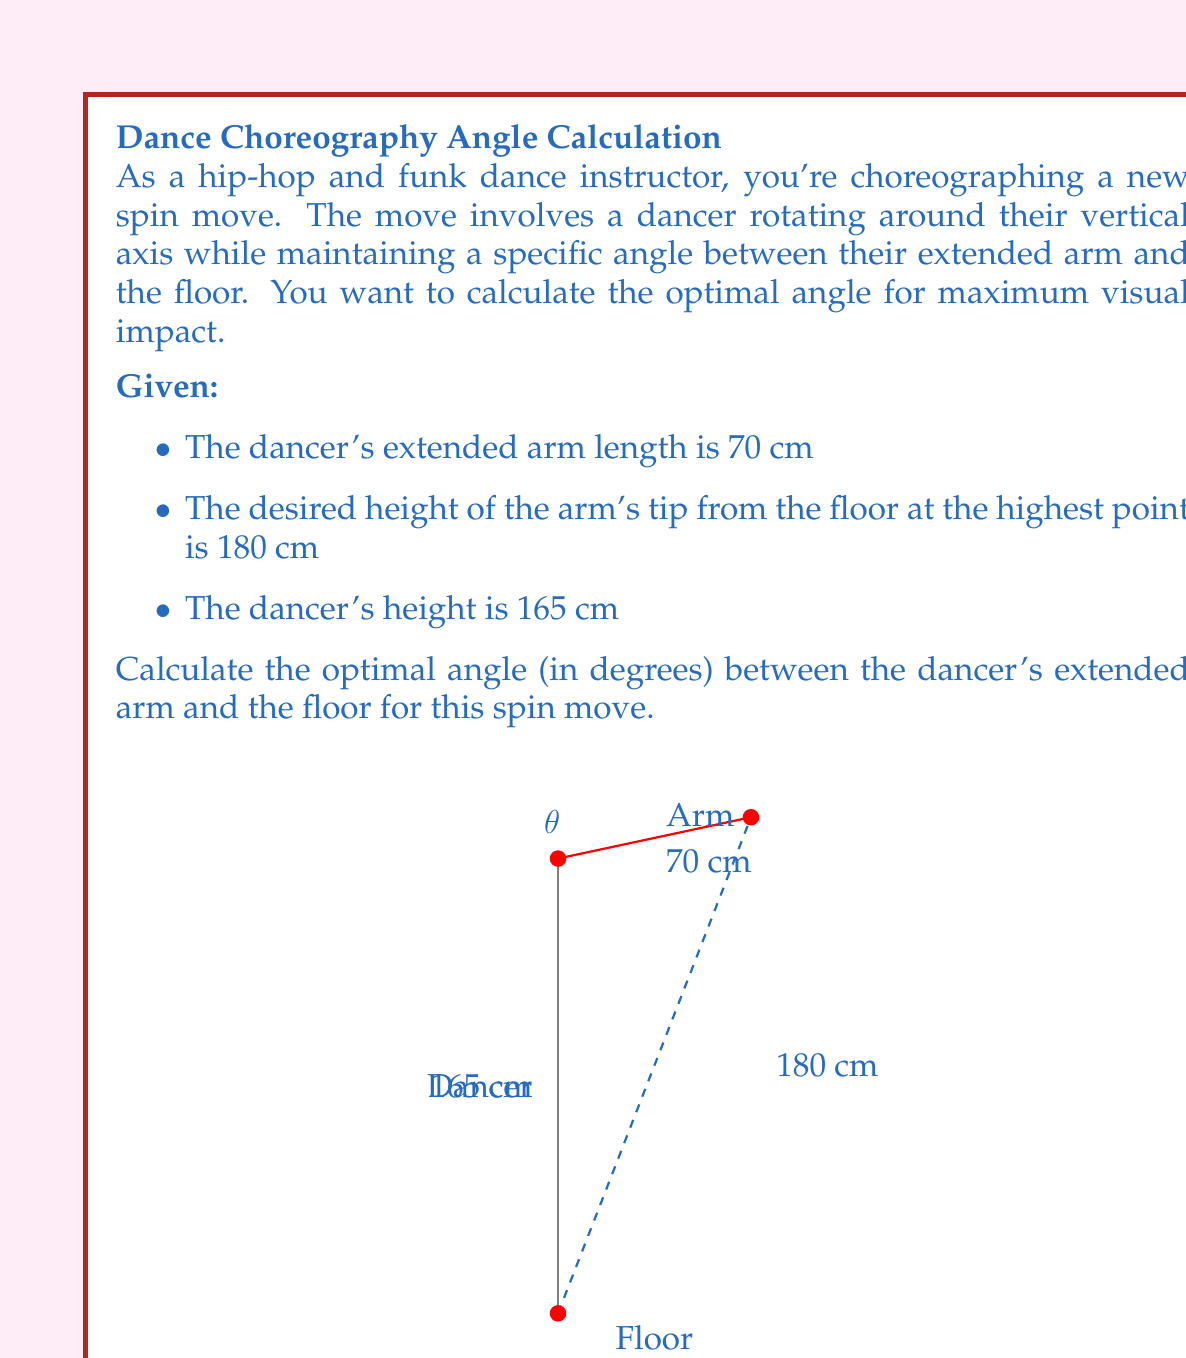Can you solve this math problem? Let's approach this step-by-step using trigonometry:

1) First, we need to identify the triangle formed by the dancer's arm and body. The arm forms the hypotenuse of a right-angled triangle.

2) We know:
   - The arm length (hypotenuse) = 70 cm
   - The dancer's height = 165 cm
   - The desired height of the arm tip = 180 cm

3) The opposite side of our triangle is the difference between the desired height and the dancer's height:
   $180 \text{ cm} - 165 \text{ cm} = 15 \text{ cm}$

4) We can now use the inverse cosine function (arccos) to find the angle. In a right-angled triangle:

   $\cos(\theta) = \frac{\text{adjacent}}{\text{hypotenuse}}$

5) In our case:
   $\cos(\theta) = \frac{15}{70} = \frac{3}{14}$

6) Therefore:
   $\theta = \arccos(\frac{3}{14})$

7) Converting to degrees:
   $\theta = \arccos(\frac{3}{14}) \cdot \frac{180}{\pi} \approx 77.87°$

8) Rounding to the nearest degree:
   $\theta \approx 78°$
Answer: $78°$ 